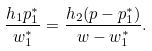Convert formula to latex. <formula><loc_0><loc_0><loc_500><loc_500>\frac { h _ { 1 } p ^ { \ast } _ { 1 } } { w ^ { \ast } _ { 1 } } = \frac { h _ { 2 } ( p - p ^ { \ast } _ { 1 } ) } { w - w ^ { \ast } _ { 1 } } .</formula> 